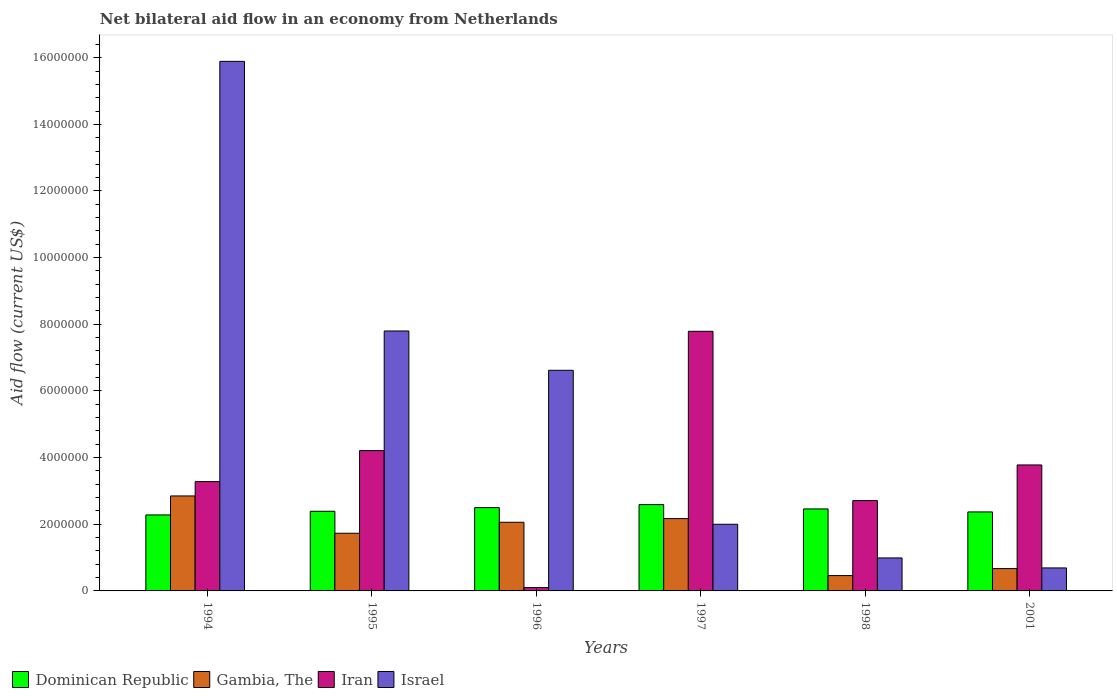How many different coloured bars are there?
Keep it short and to the point. 4. What is the label of the 4th group of bars from the left?
Provide a succinct answer. 1997. What is the net bilateral aid flow in Dominican Republic in 2001?
Ensure brevity in your answer.  2.37e+06. Across all years, what is the maximum net bilateral aid flow in Gambia, The?
Make the answer very short. 2.85e+06. Across all years, what is the minimum net bilateral aid flow in Iran?
Offer a very short reply. 1.00e+05. In which year was the net bilateral aid flow in Iran minimum?
Your response must be concise. 1996. What is the total net bilateral aid flow in Israel in the graph?
Offer a very short reply. 3.40e+07. What is the difference between the net bilateral aid flow in Gambia, The in 1997 and the net bilateral aid flow in Dominican Republic in 1996?
Provide a succinct answer. -3.30e+05. What is the average net bilateral aid flow in Gambia, The per year?
Keep it short and to the point. 1.66e+06. In the year 2001, what is the difference between the net bilateral aid flow in Iran and net bilateral aid flow in Gambia, The?
Make the answer very short. 3.11e+06. In how many years, is the net bilateral aid flow in Israel greater than 12400000 US$?
Keep it short and to the point. 1. What is the ratio of the net bilateral aid flow in Gambia, The in 1994 to that in 1997?
Offer a terse response. 1.31. What is the difference between the highest and the second highest net bilateral aid flow in Israel?
Offer a very short reply. 8.09e+06. What is the difference between the highest and the lowest net bilateral aid flow in Israel?
Give a very brief answer. 1.52e+07. Is the sum of the net bilateral aid flow in Israel in 1995 and 1998 greater than the maximum net bilateral aid flow in Gambia, The across all years?
Your response must be concise. Yes. What does the 1st bar from the left in 2001 represents?
Offer a terse response. Dominican Republic. What does the 4th bar from the right in 1997 represents?
Offer a terse response. Dominican Republic. What is the difference between two consecutive major ticks on the Y-axis?
Offer a very short reply. 2.00e+06. Are the values on the major ticks of Y-axis written in scientific E-notation?
Your response must be concise. No. Does the graph contain grids?
Your answer should be very brief. No. Where does the legend appear in the graph?
Your answer should be compact. Bottom left. What is the title of the graph?
Ensure brevity in your answer.  Net bilateral aid flow in an economy from Netherlands. What is the label or title of the X-axis?
Your answer should be compact. Years. What is the Aid flow (current US$) of Dominican Republic in 1994?
Your response must be concise. 2.28e+06. What is the Aid flow (current US$) of Gambia, The in 1994?
Provide a short and direct response. 2.85e+06. What is the Aid flow (current US$) in Iran in 1994?
Offer a very short reply. 3.28e+06. What is the Aid flow (current US$) in Israel in 1994?
Keep it short and to the point. 1.59e+07. What is the Aid flow (current US$) in Dominican Republic in 1995?
Make the answer very short. 2.39e+06. What is the Aid flow (current US$) in Gambia, The in 1995?
Offer a very short reply. 1.73e+06. What is the Aid flow (current US$) in Iran in 1995?
Your answer should be very brief. 4.21e+06. What is the Aid flow (current US$) of Israel in 1995?
Offer a very short reply. 7.80e+06. What is the Aid flow (current US$) in Dominican Republic in 1996?
Your answer should be compact. 2.50e+06. What is the Aid flow (current US$) in Gambia, The in 1996?
Your answer should be compact. 2.06e+06. What is the Aid flow (current US$) of Israel in 1996?
Keep it short and to the point. 6.62e+06. What is the Aid flow (current US$) in Dominican Republic in 1997?
Make the answer very short. 2.59e+06. What is the Aid flow (current US$) of Gambia, The in 1997?
Keep it short and to the point. 2.17e+06. What is the Aid flow (current US$) in Iran in 1997?
Provide a succinct answer. 7.79e+06. What is the Aid flow (current US$) in Dominican Republic in 1998?
Your response must be concise. 2.46e+06. What is the Aid flow (current US$) of Iran in 1998?
Keep it short and to the point. 2.71e+06. What is the Aid flow (current US$) of Israel in 1998?
Give a very brief answer. 9.90e+05. What is the Aid flow (current US$) of Dominican Republic in 2001?
Make the answer very short. 2.37e+06. What is the Aid flow (current US$) of Gambia, The in 2001?
Offer a terse response. 6.70e+05. What is the Aid flow (current US$) of Iran in 2001?
Provide a short and direct response. 3.78e+06. What is the Aid flow (current US$) of Israel in 2001?
Offer a terse response. 6.90e+05. Across all years, what is the maximum Aid flow (current US$) of Dominican Republic?
Give a very brief answer. 2.59e+06. Across all years, what is the maximum Aid flow (current US$) in Gambia, The?
Your response must be concise. 2.85e+06. Across all years, what is the maximum Aid flow (current US$) of Iran?
Offer a very short reply. 7.79e+06. Across all years, what is the maximum Aid flow (current US$) of Israel?
Provide a succinct answer. 1.59e+07. Across all years, what is the minimum Aid flow (current US$) in Dominican Republic?
Your answer should be very brief. 2.28e+06. Across all years, what is the minimum Aid flow (current US$) in Iran?
Keep it short and to the point. 1.00e+05. Across all years, what is the minimum Aid flow (current US$) in Israel?
Offer a very short reply. 6.90e+05. What is the total Aid flow (current US$) of Dominican Republic in the graph?
Your answer should be very brief. 1.46e+07. What is the total Aid flow (current US$) in Gambia, The in the graph?
Keep it short and to the point. 9.94e+06. What is the total Aid flow (current US$) in Iran in the graph?
Offer a very short reply. 2.19e+07. What is the total Aid flow (current US$) of Israel in the graph?
Keep it short and to the point. 3.40e+07. What is the difference between the Aid flow (current US$) in Dominican Republic in 1994 and that in 1995?
Give a very brief answer. -1.10e+05. What is the difference between the Aid flow (current US$) in Gambia, The in 1994 and that in 1995?
Provide a succinct answer. 1.12e+06. What is the difference between the Aid flow (current US$) in Iran in 1994 and that in 1995?
Your response must be concise. -9.30e+05. What is the difference between the Aid flow (current US$) in Israel in 1994 and that in 1995?
Your answer should be compact. 8.09e+06. What is the difference between the Aid flow (current US$) of Gambia, The in 1994 and that in 1996?
Your answer should be compact. 7.90e+05. What is the difference between the Aid flow (current US$) of Iran in 1994 and that in 1996?
Give a very brief answer. 3.18e+06. What is the difference between the Aid flow (current US$) of Israel in 1994 and that in 1996?
Keep it short and to the point. 9.27e+06. What is the difference between the Aid flow (current US$) in Dominican Republic in 1994 and that in 1997?
Give a very brief answer. -3.10e+05. What is the difference between the Aid flow (current US$) in Gambia, The in 1994 and that in 1997?
Ensure brevity in your answer.  6.80e+05. What is the difference between the Aid flow (current US$) of Iran in 1994 and that in 1997?
Keep it short and to the point. -4.51e+06. What is the difference between the Aid flow (current US$) in Israel in 1994 and that in 1997?
Your answer should be compact. 1.39e+07. What is the difference between the Aid flow (current US$) in Dominican Republic in 1994 and that in 1998?
Give a very brief answer. -1.80e+05. What is the difference between the Aid flow (current US$) of Gambia, The in 1994 and that in 1998?
Give a very brief answer. 2.39e+06. What is the difference between the Aid flow (current US$) of Iran in 1994 and that in 1998?
Give a very brief answer. 5.70e+05. What is the difference between the Aid flow (current US$) in Israel in 1994 and that in 1998?
Your response must be concise. 1.49e+07. What is the difference between the Aid flow (current US$) of Gambia, The in 1994 and that in 2001?
Offer a very short reply. 2.18e+06. What is the difference between the Aid flow (current US$) of Iran in 1994 and that in 2001?
Your answer should be very brief. -5.00e+05. What is the difference between the Aid flow (current US$) in Israel in 1994 and that in 2001?
Provide a succinct answer. 1.52e+07. What is the difference between the Aid flow (current US$) in Dominican Republic in 1995 and that in 1996?
Your answer should be compact. -1.10e+05. What is the difference between the Aid flow (current US$) of Gambia, The in 1995 and that in 1996?
Ensure brevity in your answer.  -3.30e+05. What is the difference between the Aid flow (current US$) in Iran in 1995 and that in 1996?
Offer a very short reply. 4.11e+06. What is the difference between the Aid flow (current US$) of Israel in 1995 and that in 1996?
Keep it short and to the point. 1.18e+06. What is the difference between the Aid flow (current US$) in Gambia, The in 1995 and that in 1997?
Ensure brevity in your answer.  -4.40e+05. What is the difference between the Aid flow (current US$) of Iran in 1995 and that in 1997?
Offer a terse response. -3.58e+06. What is the difference between the Aid flow (current US$) in Israel in 1995 and that in 1997?
Ensure brevity in your answer.  5.80e+06. What is the difference between the Aid flow (current US$) of Gambia, The in 1995 and that in 1998?
Your response must be concise. 1.27e+06. What is the difference between the Aid flow (current US$) in Iran in 1995 and that in 1998?
Offer a very short reply. 1.50e+06. What is the difference between the Aid flow (current US$) of Israel in 1995 and that in 1998?
Offer a terse response. 6.81e+06. What is the difference between the Aid flow (current US$) in Gambia, The in 1995 and that in 2001?
Offer a very short reply. 1.06e+06. What is the difference between the Aid flow (current US$) of Iran in 1995 and that in 2001?
Offer a very short reply. 4.30e+05. What is the difference between the Aid flow (current US$) in Israel in 1995 and that in 2001?
Ensure brevity in your answer.  7.11e+06. What is the difference between the Aid flow (current US$) in Iran in 1996 and that in 1997?
Make the answer very short. -7.69e+06. What is the difference between the Aid flow (current US$) in Israel in 1996 and that in 1997?
Your answer should be compact. 4.62e+06. What is the difference between the Aid flow (current US$) in Dominican Republic in 1996 and that in 1998?
Offer a terse response. 4.00e+04. What is the difference between the Aid flow (current US$) of Gambia, The in 1996 and that in 1998?
Provide a succinct answer. 1.60e+06. What is the difference between the Aid flow (current US$) of Iran in 1996 and that in 1998?
Your answer should be compact. -2.61e+06. What is the difference between the Aid flow (current US$) of Israel in 1996 and that in 1998?
Provide a short and direct response. 5.63e+06. What is the difference between the Aid flow (current US$) of Dominican Republic in 1996 and that in 2001?
Your answer should be very brief. 1.30e+05. What is the difference between the Aid flow (current US$) in Gambia, The in 1996 and that in 2001?
Your response must be concise. 1.39e+06. What is the difference between the Aid flow (current US$) in Iran in 1996 and that in 2001?
Ensure brevity in your answer.  -3.68e+06. What is the difference between the Aid flow (current US$) of Israel in 1996 and that in 2001?
Your answer should be compact. 5.93e+06. What is the difference between the Aid flow (current US$) in Gambia, The in 1997 and that in 1998?
Make the answer very short. 1.71e+06. What is the difference between the Aid flow (current US$) in Iran in 1997 and that in 1998?
Your response must be concise. 5.08e+06. What is the difference between the Aid flow (current US$) in Israel in 1997 and that in 1998?
Ensure brevity in your answer.  1.01e+06. What is the difference between the Aid flow (current US$) of Gambia, The in 1997 and that in 2001?
Give a very brief answer. 1.50e+06. What is the difference between the Aid flow (current US$) of Iran in 1997 and that in 2001?
Offer a terse response. 4.01e+06. What is the difference between the Aid flow (current US$) of Israel in 1997 and that in 2001?
Your answer should be compact. 1.31e+06. What is the difference between the Aid flow (current US$) in Dominican Republic in 1998 and that in 2001?
Offer a terse response. 9.00e+04. What is the difference between the Aid flow (current US$) of Iran in 1998 and that in 2001?
Offer a terse response. -1.07e+06. What is the difference between the Aid flow (current US$) in Dominican Republic in 1994 and the Aid flow (current US$) in Gambia, The in 1995?
Ensure brevity in your answer.  5.50e+05. What is the difference between the Aid flow (current US$) of Dominican Republic in 1994 and the Aid flow (current US$) of Iran in 1995?
Make the answer very short. -1.93e+06. What is the difference between the Aid flow (current US$) in Dominican Republic in 1994 and the Aid flow (current US$) in Israel in 1995?
Ensure brevity in your answer.  -5.52e+06. What is the difference between the Aid flow (current US$) of Gambia, The in 1994 and the Aid flow (current US$) of Iran in 1995?
Keep it short and to the point. -1.36e+06. What is the difference between the Aid flow (current US$) of Gambia, The in 1994 and the Aid flow (current US$) of Israel in 1995?
Offer a very short reply. -4.95e+06. What is the difference between the Aid flow (current US$) in Iran in 1994 and the Aid flow (current US$) in Israel in 1995?
Keep it short and to the point. -4.52e+06. What is the difference between the Aid flow (current US$) of Dominican Republic in 1994 and the Aid flow (current US$) of Gambia, The in 1996?
Ensure brevity in your answer.  2.20e+05. What is the difference between the Aid flow (current US$) of Dominican Republic in 1994 and the Aid flow (current US$) of Iran in 1996?
Your answer should be very brief. 2.18e+06. What is the difference between the Aid flow (current US$) in Dominican Republic in 1994 and the Aid flow (current US$) in Israel in 1996?
Offer a very short reply. -4.34e+06. What is the difference between the Aid flow (current US$) of Gambia, The in 1994 and the Aid flow (current US$) of Iran in 1996?
Your answer should be very brief. 2.75e+06. What is the difference between the Aid flow (current US$) of Gambia, The in 1994 and the Aid flow (current US$) of Israel in 1996?
Offer a terse response. -3.77e+06. What is the difference between the Aid flow (current US$) in Iran in 1994 and the Aid flow (current US$) in Israel in 1996?
Your answer should be compact. -3.34e+06. What is the difference between the Aid flow (current US$) in Dominican Republic in 1994 and the Aid flow (current US$) in Iran in 1997?
Provide a short and direct response. -5.51e+06. What is the difference between the Aid flow (current US$) in Dominican Republic in 1994 and the Aid flow (current US$) in Israel in 1997?
Make the answer very short. 2.80e+05. What is the difference between the Aid flow (current US$) in Gambia, The in 1994 and the Aid flow (current US$) in Iran in 1997?
Keep it short and to the point. -4.94e+06. What is the difference between the Aid flow (current US$) in Gambia, The in 1994 and the Aid flow (current US$) in Israel in 1997?
Provide a succinct answer. 8.50e+05. What is the difference between the Aid flow (current US$) in Iran in 1994 and the Aid flow (current US$) in Israel in 1997?
Provide a short and direct response. 1.28e+06. What is the difference between the Aid flow (current US$) of Dominican Republic in 1994 and the Aid flow (current US$) of Gambia, The in 1998?
Ensure brevity in your answer.  1.82e+06. What is the difference between the Aid flow (current US$) in Dominican Republic in 1994 and the Aid flow (current US$) in Iran in 1998?
Provide a succinct answer. -4.30e+05. What is the difference between the Aid flow (current US$) in Dominican Republic in 1994 and the Aid flow (current US$) in Israel in 1998?
Your answer should be very brief. 1.29e+06. What is the difference between the Aid flow (current US$) of Gambia, The in 1994 and the Aid flow (current US$) of Iran in 1998?
Give a very brief answer. 1.40e+05. What is the difference between the Aid flow (current US$) in Gambia, The in 1994 and the Aid flow (current US$) in Israel in 1998?
Your response must be concise. 1.86e+06. What is the difference between the Aid flow (current US$) in Iran in 1994 and the Aid flow (current US$) in Israel in 1998?
Your answer should be compact. 2.29e+06. What is the difference between the Aid flow (current US$) of Dominican Republic in 1994 and the Aid flow (current US$) of Gambia, The in 2001?
Make the answer very short. 1.61e+06. What is the difference between the Aid flow (current US$) in Dominican Republic in 1994 and the Aid flow (current US$) in Iran in 2001?
Your response must be concise. -1.50e+06. What is the difference between the Aid flow (current US$) of Dominican Republic in 1994 and the Aid flow (current US$) of Israel in 2001?
Make the answer very short. 1.59e+06. What is the difference between the Aid flow (current US$) in Gambia, The in 1994 and the Aid flow (current US$) in Iran in 2001?
Offer a very short reply. -9.30e+05. What is the difference between the Aid flow (current US$) in Gambia, The in 1994 and the Aid flow (current US$) in Israel in 2001?
Make the answer very short. 2.16e+06. What is the difference between the Aid flow (current US$) in Iran in 1994 and the Aid flow (current US$) in Israel in 2001?
Your response must be concise. 2.59e+06. What is the difference between the Aid flow (current US$) of Dominican Republic in 1995 and the Aid flow (current US$) of Gambia, The in 1996?
Your answer should be compact. 3.30e+05. What is the difference between the Aid flow (current US$) of Dominican Republic in 1995 and the Aid flow (current US$) of Iran in 1996?
Provide a short and direct response. 2.29e+06. What is the difference between the Aid flow (current US$) of Dominican Republic in 1995 and the Aid flow (current US$) of Israel in 1996?
Provide a succinct answer. -4.23e+06. What is the difference between the Aid flow (current US$) in Gambia, The in 1995 and the Aid flow (current US$) in Iran in 1996?
Make the answer very short. 1.63e+06. What is the difference between the Aid flow (current US$) in Gambia, The in 1995 and the Aid flow (current US$) in Israel in 1996?
Make the answer very short. -4.89e+06. What is the difference between the Aid flow (current US$) of Iran in 1995 and the Aid flow (current US$) of Israel in 1996?
Give a very brief answer. -2.41e+06. What is the difference between the Aid flow (current US$) in Dominican Republic in 1995 and the Aid flow (current US$) in Iran in 1997?
Offer a terse response. -5.40e+06. What is the difference between the Aid flow (current US$) of Dominican Republic in 1995 and the Aid flow (current US$) of Israel in 1997?
Your answer should be very brief. 3.90e+05. What is the difference between the Aid flow (current US$) in Gambia, The in 1995 and the Aid flow (current US$) in Iran in 1997?
Offer a terse response. -6.06e+06. What is the difference between the Aid flow (current US$) in Gambia, The in 1995 and the Aid flow (current US$) in Israel in 1997?
Give a very brief answer. -2.70e+05. What is the difference between the Aid flow (current US$) in Iran in 1995 and the Aid flow (current US$) in Israel in 1997?
Make the answer very short. 2.21e+06. What is the difference between the Aid flow (current US$) in Dominican Republic in 1995 and the Aid flow (current US$) in Gambia, The in 1998?
Offer a very short reply. 1.93e+06. What is the difference between the Aid flow (current US$) of Dominican Republic in 1995 and the Aid flow (current US$) of Iran in 1998?
Offer a terse response. -3.20e+05. What is the difference between the Aid flow (current US$) of Dominican Republic in 1995 and the Aid flow (current US$) of Israel in 1998?
Make the answer very short. 1.40e+06. What is the difference between the Aid flow (current US$) of Gambia, The in 1995 and the Aid flow (current US$) of Iran in 1998?
Your answer should be very brief. -9.80e+05. What is the difference between the Aid flow (current US$) of Gambia, The in 1995 and the Aid flow (current US$) of Israel in 1998?
Provide a short and direct response. 7.40e+05. What is the difference between the Aid flow (current US$) in Iran in 1995 and the Aid flow (current US$) in Israel in 1998?
Ensure brevity in your answer.  3.22e+06. What is the difference between the Aid flow (current US$) of Dominican Republic in 1995 and the Aid flow (current US$) of Gambia, The in 2001?
Provide a succinct answer. 1.72e+06. What is the difference between the Aid flow (current US$) of Dominican Republic in 1995 and the Aid flow (current US$) of Iran in 2001?
Offer a very short reply. -1.39e+06. What is the difference between the Aid flow (current US$) of Dominican Republic in 1995 and the Aid flow (current US$) of Israel in 2001?
Offer a terse response. 1.70e+06. What is the difference between the Aid flow (current US$) of Gambia, The in 1995 and the Aid flow (current US$) of Iran in 2001?
Make the answer very short. -2.05e+06. What is the difference between the Aid flow (current US$) in Gambia, The in 1995 and the Aid flow (current US$) in Israel in 2001?
Give a very brief answer. 1.04e+06. What is the difference between the Aid flow (current US$) of Iran in 1995 and the Aid flow (current US$) of Israel in 2001?
Provide a short and direct response. 3.52e+06. What is the difference between the Aid flow (current US$) in Dominican Republic in 1996 and the Aid flow (current US$) in Iran in 1997?
Your response must be concise. -5.29e+06. What is the difference between the Aid flow (current US$) in Dominican Republic in 1996 and the Aid flow (current US$) in Israel in 1997?
Your answer should be very brief. 5.00e+05. What is the difference between the Aid flow (current US$) in Gambia, The in 1996 and the Aid flow (current US$) in Iran in 1997?
Ensure brevity in your answer.  -5.73e+06. What is the difference between the Aid flow (current US$) in Gambia, The in 1996 and the Aid flow (current US$) in Israel in 1997?
Make the answer very short. 6.00e+04. What is the difference between the Aid flow (current US$) of Iran in 1996 and the Aid flow (current US$) of Israel in 1997?
Provide a succinct answer. -1.90e+06. What is the difference between the Aid flow (current US$) of Dominican Republic in 1996 and the Aid flow (current US$) of Gambia, The in 1998?
Offer a very short reply. 2.04e+06. What is the difference between the Aid flow (current US$) of Dominican Republic in 1996 and the Aid flow (current US$) of Iran in 1998?
Ensure brevity in your answer.  -2.10e+05. What is the difference between the Aid flow (current US$) in Dominican Republic in 1996 and the Aid flow (current US$) in Israel in 1998?
Provide a succinct answer. 1.51e+06. What is the difference between the Aid flow (current US$) in Gambia, The in 1996 and the Aid flow (current US$) in Iran in 1998?
Provide a succinct answer. -6.50e+05. What is the difference between the Aid flow (current US$) in Gambia, The in 1996 and the Aid flow (current US$) in Israel in 1998?
Provide a short and direct response. 1.07e+06. What is the difference between the Aid flow (current US$) in Iran in 1996 and the Aid flow (current US$) in Israel in 1998?
Keep it short and to the point. -8.90e+05. What is the difference between the Aid flow (current US$) of Dominican Republic in 1996 and the Aid flow (current US$) of Gambia, The in 2001?
Provide a short and direct response. 1.83e+06. What is the difference between the Aid flow (current US$) in Dominican Republic in 1996 and the Aid flow (current US$) in Iran in 2001?
Provide a succinct answer. -1.28e+06. What is the difference between the Aid flow (current US$) in Dominican Republic in 1996 and the Aid flow (current US$) in Israel in 2001?
Provide a succinct answer. 1.81e+06. What is the difference between the Aid flow (current US$) in Gambia, The in 1996 and the Aid flow (current US$) in Iran in 2001?
Offer a terse response. -1.72e+06. What is the difference between the Aid flow (current US$) in Gambia, The in 1996 and the Aid flow (current US$) in Israel in 2001?
Offer a very short reply. 1.37e+06. What is the difference between the Aid flow (current US$) of Iran in 1996 and the Aid flow (current US$) of Israel in 2001?
Offer a terse response. -5.90e+05. What is the difference between the Aid flow (current US$) of Dominican Republic in 1997 and the Aid flow (current US$) of Gambia, The in 1998?
Keep it short and to the point. 2.13e+06. What is the difference between the Aid flow (current US$) of Dominican Republic in 1997 and the Aid flow (current US$) of Iran in 1998?
Provide a succinct answer. -1.20e+05. What is the difference between the Aid flow (current US$) in Dominican Republic in 1997 and the Aid flow (current US$) in Israel in 1998?
Provide a succinct answer. 1.60e+06. What is the difference between the Aid flow (current US$) of Gambia, The in 1997 and the Aid flow (current US$) of Iran in 1998?
Ensure brevity in your answer.  -5.40e+05. What is the difference between the Aid flow (current US$) in Gambia, The in 1997 and the Aid flow (current US$) in Israel in 1998?
Provide a succinct answer. 1.18e+06. What is the difference between the Aid flow (current US$) of Iran in 1997 and the Aid flow (current US$) of Israel in 1998?
Offer a very short reply. 6.80e+06. What is the difference between the Aid flow (current US$) in Dominican Republic in 1997 and the Aid flow (current US$) in Gambia, The in 2001?
Make the answer very short. 1.92e+06. What is the difference between the Aid flow (current US$) of Dominican Republic in 1997 and the Aid flow (current US$) of Iran in 2001?
Give a very brief answer. -1.19e+06. What is the difference between the Aid flow (current US$) of Dominican Republic in 1997 and the Aid flow (current US$) of Israel in 2001?
Offer a very short reply. 1.90e+06. What is the difference between the Aid flow (current US$) of Gambia, The in 1997 and the Aid flow (current US$) of Iran in 2001?
Keep it short and to the point. -1.61e+06. What is the difference between the Aid flow (current US$) in Gambia, The in 1997 and the Aid flow (current US$) in Israel in 2001?
Keep it short and to the point. 1.48e+06. What is the difference between the Aid flow (current US$) in Iran in 1997 and the Aid flow (current US$) in Israel in 2001?
Your response must be concise. 7.10e+06. What is the difference between the Aid flow (current US$) in Dominican Republic in 1998 and the Aid flow (current US$) in Gambia, The in 2001?
Offer a very short reply. 1.79e+06. What is the difference between the Aid flow (current US$) of Dominican Republic in 1998 and the Aid flow (current US$) of Iran in 2001?
Make the answer very short. -1.32e+06. What is the difference between the Aid flow (current US$) of Dominican Republic in 1998 and the Aid flow (current US$) of Israel in 2001?
Offer a very short reply. 1.77e+06. What is the difference between the Aid flow (current US$) in Gambia, The in 1998 and the Aid flow (current US$) in Iran in 2001?
Offer a terse response. -3.32e+06. What is the difference between the Aid flow (current US$) in Gambia, The in 1998 and the Aid flow (current US$) in Israel in 2001?
Your answer should be very brief. -2.30e+05. What is the difference between the Aid flow (current US$) in Iran in 1998 and the Aid flow (current US$) in Israel in 2001?
Ensure brevity in your answer.  2.02e+06. What is the average Aid flow (current US$) in Dominican Republic per year?
Offer a very short reply. 2.43e+06. What is the average Aid flow (current US$) of Gambia, The per year?
Provide a succinct answer. 1.66e+06. What is the average Aid flow (current US$) in Iran per year?
Ensure brevity in your answer.  3.64e+06. What is the average Aid flow (current US$) of Israel per year?
Make the answer very short. 5.66e+06. In the year 1994, what is the difference between the Aid flow (current US$) in Dominican Republic and Aid flow (current US$) in Gambia, The?
Your response must be concise. -5.70e+05. In the year 1994, what is the difference between the Aid flow (current US$) of Dominican Republic and Aid flow (current US$) of Israel?
Offer a very short reply. -1.36e+07. In the year 1994, what is the difference between the Aid flow (current US$) in Gambia, The and Aid flow (current US$) in Iran?
Provide a succinct answer. -4.30e+05. In the year 1994, what is the difference between the Aid flow (current US$) in Gambia, The and Aid flow (current US$) in Israel?
Offer a very short reply. -1.30e+07. In the year 1994, what is the difference between the Aid flow (current US$) of Iran and Aid flow (current US$) of Israel?
Offer a very short reply. -1.26e+07. In the year 1995, what is the difference between the Aid flow (current US$) in Dominican Republic and Aid flow (current US$) in Gambia, The?
Keep it short and to the point. 6.60e+05. In the year 1995, what is the difference between the Aid flow (current US$) in Dominican Republic and Aid flow (current US$) in Iran?
Give a very brief answer. -1.82e+06. In the year 1995, what is the difference between the Aid flow (current US$) in Dominican Republic and Aid flow (current US$) in Israel?
Give a very brief answer. -5.41e+06. In the year 1995, what is the difference between the Aid flow (current US$) of Gambia, The and Aid flow (current US$) of Iran?
Make the answer very short. -2.48e+06. In the year 1995, what is the difference between the Aid flow (current US$) in Gambia, The and Aid flow (current US$) in Israel?
Keep it short and to the point. -6.07e+06. In the year 1995, what is the difference between the Aid flow (current US$) in Iran and Aid flow (current US$) in Israel?
Your answer should be compact. -3.59e+06. In the year 1996, what is the difference between the Aid flow (current US$) in Dominican Republic and Aid flow (current US$) in Gambia, The?
Keep it short and to the point. 4.40e+05. In the year 1996, what is the difference between the Aid flow (current US$) in Dominican Republic and Aid flow (current US$) in Iran?
Your response must be concise. 2.40e+06. In the year 1996, what is the difference between the Aid flow (current US$) of Dominican Republic and Aid flow (current US$) of Israel?
Offer a terse response. -4.12e+06. In the year 1996, what is the difference between the Aid flow (current US$) of Gambia, The and Aid flow (current US$) of Iran?
Offer a very short reply. 1.96e+06. In the year 1996, what is the difference between the Aid flow (current US$) in Gambia, The and Aid flow (current US$) in Israel?
Give a very brief answer. -4.56e+06. In the year 1996, what is the difference between the Aid flow (current US$) of Iran and Aid flow (current US$) of Israel?
Make the answer very short. -6.52e+06. In the year 1997, what is the difference between the Aid flow (current US$) in Dominican Republic and Aid flow (current US$) in Gambia, The?
Give a very brief answer. 4.20e+05. In the year 1997, what is the difference between the Aid flow (current US$) in Dominican Republic and Aid flow (current US$) in Iran?
Keep it short and to the point. -5.20e+06. In the year 1997, what is the difference between the Aid flow (current US$) of Dominican Republic and Aid flow (current US$) of Israel?
Ensure brevity in your answer.  5.90e+05. In the year 1997, what is the difference between the Aid flow (current US$) of Gambia, The and Aid flow (current US$) of Iran?
Your answer should be compact. -5.62e+06. In the year 1997, what is the difference between the Aid flow (current US$) of Iran and Aid flow (current US$) of Israel?
Provide a short and direct response. 5.79e+06. In the year 1998, what is the difference between the Aid flow (current US$) of Dominican Republic and Aid flow (current US$) of Iran?
Ensure brevity in your answer.  -2.50e+05. In the year 1998, what is the difference between the Aid flow (current US$) in Dominican Republic and Aid flow (current US$) in Israel?
Offer a very short reply. 1.47e+06. In the year 1998, what is the difference between the Aid flow (current US$) in Gambia, The and Aid flow (current US$) in Iran?
Offer a very short reply. -2.25e+06. In the year 1998, what is the difference between the Aid flow (current US$) in Gambia, The and Aid flow (current US$) in Israel?
Offer a terse response. -5.30e+05. In the year 1998, what is the difference between the Aid flow (current US$) in Iran and Aid flow (current US$) in Israel?
Provide a short and direct response. 1.72e+06. In the year 2001, what is the difference between the Aid flow (current US$) in Dominican Republic and Aid flow (current US$) in Gambia, The?
Ensure brevity in your answer.  1.70e+06. In the year 2001, what is the difference between the Aid flow (current US$) of Dominican Republic and Aid flow (current US$) of Iran?
Make the answer very short. -1.41e+06. In the year 2001, what is the difference between the Aid flow (current US$) in Dominican Republic and Aid flow (current US$) in Israel?
Ensure brevity in your answer.  1.68e+06. In the year 2001, what is the difference between the Aid flow (current US$) of Gambia, The and Aid flow (current US$) of Iran?
Make the answer very short. -3.11e+06. In the year 2001, what is the difference between the Aid flow (current US$) in Iran and Aid flow (current US$) in Israel?
Your answer should be compact. 3.09e+06. What is the ratio of the Aid flow (current US$) in Dominican Republic in 1994 to that in 1995?
Your answer should be compact. 0.95. What is the ratio of the Aid flow (current US$) of Gambia, The in 1994 to that in 1995?
Make the answer very short. 1.65. What is the ratio of the Aid flow (current US$) in Iran in 1994 to that in 1995?
Your answer should be compact. 0.78. What is the ratio of the Aid flow (current US$) of Israel in 1994 to that in 1995?
Your answer should be compact. 2.04. What is the ratio of the Aid flow (current US$) in Dominican Republic in 1994 to that in 1996?
Make the answer very short. 0.91. What is the ratio of the Aid flow (current US$) in Gambia, The in 1994 to that in 1996?
Make the answer very short. 1.38. What is the ratio of the Aid flow (current US$) in Iran in 1994 to that in 1996?
Keep it short and to the point. 32.8. What is the ratio of the Aid flow (current US$) in Israel in 1994 to that in 1996?
Offer a very short reply. 2.4. What is the ratio of the Aid flow (current US$) in Dominican Republic in 1994 to that in 1997?
Offer a very short reply. 0.88. What is the ratio of the Aid flow (current US$) of Gambia, The in 1994 to that in 1997?
Your answer should be compact. 1.31. What is the ratio of the Aid flow (current US$) in Iran in 1994 to that in 1997?
Keep it short and to the point. 0.42. What is the ratio of the Aid flow (current US$) in Israel in 1994 to that in 1997?
Give a very brief answer. 7.95. What is the ratio of the Aid flow (current US$) in Dominican Republic in 1994 to that in 1998?
Give a very brief answer. 0.93. What is the ratio of the Aid flow (current US$) in Gambia, The in 1994 to that in 1998?
Your answer should be compact. 6.2. What is the ratio of the Aid flow (current US$) of Iran in 1994 to that in 1998?
Your answer should be very brief. 1.21. What is the ratio of the Aid flow (current US$) in Israel in 1994 to that in 1998?
Keep it short and to the point. 16.05. What is the ratio of the Aid flow (current US$) in Dominican Republic in 1994 to that in 2001?
Your answer should be compact. 0.96. What is the ratio of the Aid flow (current US$) of Gambia, The in 1994 to that in 2001?
Your answer should be very brief. 4.25. What is the ratio of the Aid flow (current US$) of Iran in 1994 to that in 2001?
Make the answer very short. 0.87. What is the ratio of the Aid flow (current US$) in Israel in 1994 to that in 2001?
Your answer should be very brief. 23.03. What is the ratio of the Aid flow (current US$) of Dominican Republic in 1995 to that in 1996?
Offer a terse response. 0.96. What is the ratio of the Aid flow (current US$) in Gambia, The in 1995 to that in 1996?
Make the answer very short. 0.84. What is the ratio of the Aid flow (current US$) in Iran in 1995 to that in 1996?
Give a very brief answer. 42.1. What is the ratio of the Aid flow (current US$) of Israel in 1995 to that in 1996?
Ensure brevity in your answer.  1.18. What is the ratio of the Aid flow (current US$) of Dominican Republic in 1995 to that in 1997?
Provide a succinct answer. 0.92. What is the ratio of the Aid flow (current US$) in Gambia, The in 1995 to that in 1997?
Provide a succinct answer. 0.8. What is the ratio of the Aid flow (current US$) of Iran in 1995 to that in 1997?
Make the answer very short. 0.54. What is the ratio of the Aid flow (current US$) of Dominican Republic in 1995 to that in 1998?
Your answer should be compact. 0.97. What is the ratio of the Aid flow (current US$) in Gambia, The in 1995 to that in 1998?
Provide a short and direct response. 3.76. What is the ratio of the Aid flow (current US$) of Iran in 1995 to that in 1998?
Provide a succinct answer. 1.55. What is the ratio of the Aid flow (current US$) of Israel in 1995 to that in 1998?
Offer a very short reply. 7.88. What is the ratio of the Aid flow (current US$) of Dominican Republic in 1995 to that in 2001?
Ensure brevity in your answer.  1.01. What is the ratio of the Aid flow (current US$) in Gambia, The in 1995 to that in 2001?
Give a very brief answer. 2.58. What is the ratio of the Aid flow (current US$) of Iran in 1995 to that in 2001?
Keep it short and to the point. 1.11. What is the ratio of the Aid flow (current US$) in Israel in 1995 to that in 2001?
Make the answer very short. 11.3. What is the ratio of the Aid flow (current US$) of Dominican Republic in 1996 to that in 1997?
Keep it short and to the point. 0.97. What is the ratio of the Aid flow (current US$) of Gambia, The in 1996 to that in 1997?
Offer a terse response. 0.95. What is the ratio of the Aid flow (current US$) in Iran in 1996 to that in 1997?
Offer a terse response. 0.01. What is the ratio of the Aid flow (current US$) of Israel in 1996 to that in 1997?
Provide a succinct answer. 3.31. What is the ratio of the Aid flow (current US$) of Dominican Republic in 1996 to that in 1998?
Make the answer very short. 1.02. What is the ratio of the Aid flow (current US$) of Gambia, The in 1996 to that in 1998?
Your response must be concise. 4.48. What is the ratio of the Aid flow (current US$) in Iran in 1996 to that in 1998?
Ensure brevity in your answer.  0.04. What is the ratio of the Aid flow (current US$) in Israel in 1996 to that in 1998?
Offer a very short reply. 6.69. What is the ratio of the Aid flow (current US$) of Dominican Republic in 1996 to that in 2001?
Keep it short and to the point. 1.05. What is the ratio of the Aid flow (current US$) of Gambia, The in 1996 to that in 2001?
Offer a terse response. 3.07. What is the ratio of the Aid flow (current US$) in Iran in 1996 to that in 2001?
Make the answer very short. 0.03. What is the ratio of the Aid flow (current US$) of Israel in 1996 to that in 2001?
Your answer should be compact. 9.59. What is the ratio of the Aid flow (current US$) of Dominican Republic in 1997 to that in 1998?
Your answer should be very brief. 1.05. What is the ratio of the Aid flow (current US$) of Gambia, The in 1997 to that in 1998?
Provide a succinct answer. 4.72. What is the ratio of the Aid flow (current US$) in Iran in 1997 to that in 1998?
Ensure brevity in your answer.  2.87. What is the ratio of the Aid flow (current US$) of Israel in 1997 to that in 1998?
Your response must be concise. 2.02. What is the ratio of the Aid flow (current US$) of Dominican Republic in 1997 to that in 2001?
Your answer should be compact. 1.09. What is the ratio of the Aid flow (current US$) of Gambia, The in 1997 to that in 2001?
Keep it short and to the point. 3.24. What is the ratio of the Aid flow (current US$) in Iran in 1997 to that in 2001?
Provide a succinct answer. 2.06. What is the ratio of the Aid flow (current US$) in Israel in 1997 to that in 2001?
Keep it short and to the point. 2.9. What is the ratio of the Aid flow (current US$) of Dominican Republic in 1998 to that in 2001?
Provide a succinct answer. 1.04. What is the ratio of the Aid flow (current US$) of Gambia, The in 1998 to that in 2001?
Provide a short and direct response. 0.69. What is the ratio of the Aid flow (current US$) in Iran in 1998 to that in 2001?
Your answer should be very brief. 0.72. What is the ratio of the Aid flow (current US$) of Israel in 1998 to that in 2001?
Ensure brevity in your answer.  1.43. What is the difference between the highest and the second highest Aid flow (current US$) in Gambia, The?
Your answer should be compact. 6.80e+05. What is the difference between the highest and the second highest Aid flow (current US$) in Iran?
Make the answer very short. 3.58e+06. What is the difference between the highest and the second highest Aid flow (current US$) in Israel?
Ensure brevity in your answer.  8.09e+06. What is the difference between the highest and the lowest Aid flow (current US$) of Gambia, The?
Your answer should be very brief. 2.39e+06. What is the difference between the highest and the lowest Aid flow (current US$) in Iran?
Your answer should be very brief. 7.69e+06. What is the difference between the highest and the lowest Aid flow (current US$) in Israel?
Offer a terse response. 1.52e+07. 